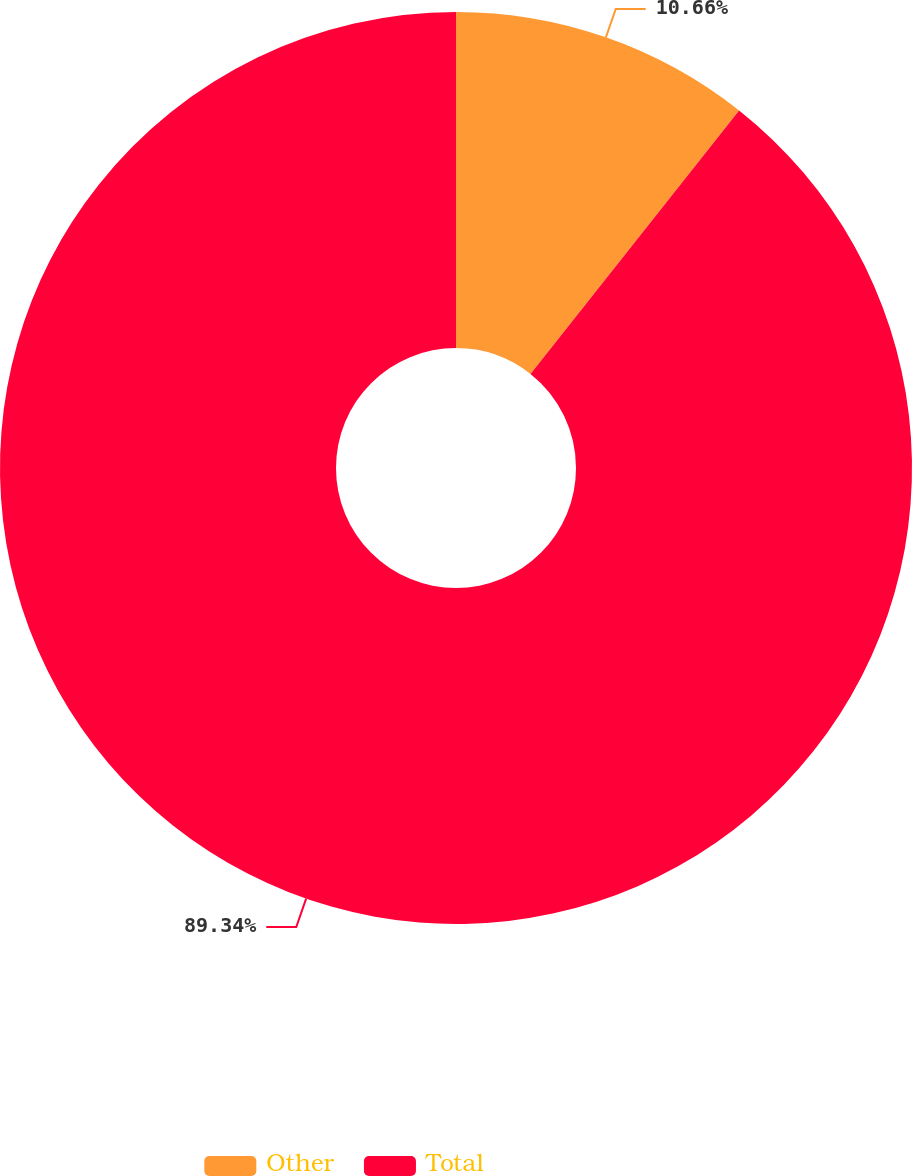Convert chart. <chart><loc_0><loc_0><loc_500><loc_500><pie_chart><fcel>Other<fcel>Total<nl><fcel>10.66%<fcel>89.34%<nl></chart> 